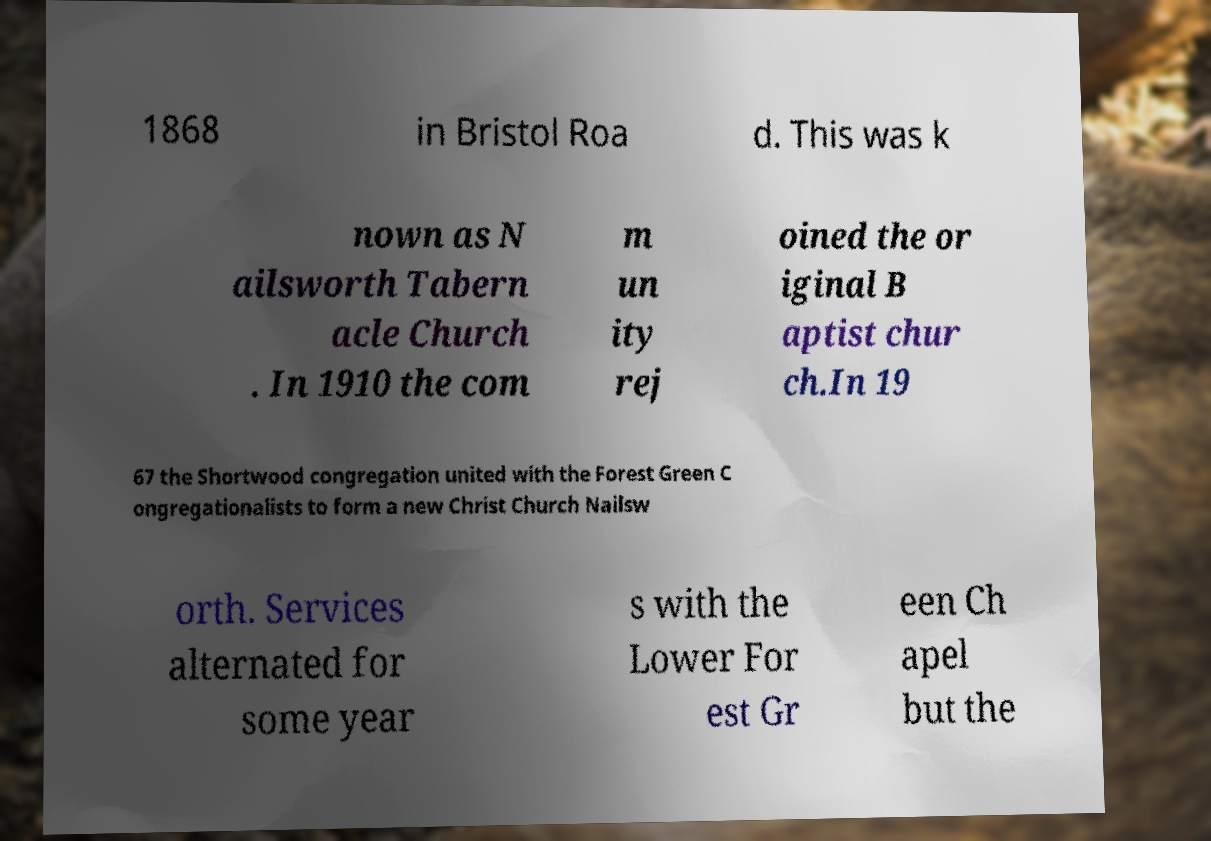I need the written content from this picture converted into text. Can you do that? 1868 in Bristol Roa d. This was k nown as N ailsworth Tabern acle Church . In 1910 the com m un ity rej oined the or iginal B aptist chur ch.In 19 67 the Shortwood congregation united with the Forest Green C ongregationalists to form a new Christ Church Nailsw orth. Services alternated for some year s with the Lower For est Gr een Ch apel but the 